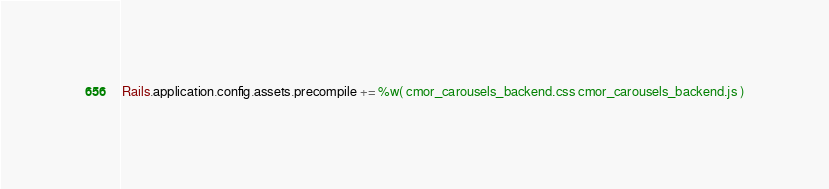<code> <loc_0><loc_0><loc_500><loc_500><_Ruby_>Rails.application.config.assets.precompile += %w( cmor_carousels_backend.css cmor_carousels_backend.js )</code> 